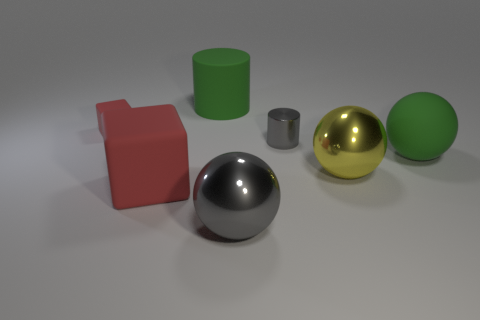There is a gray ball that is made of the same material as the small gray object; what size is it?
Your response must be concise. Large. The cylinder that is made of the same material as the tiny cube is what color?
Make the answer very short. Green. Is there a gray shiny object of the same size as the yellow metal sphere?
Keep it short and to the point. Yes. There is another green thing that is the same shape as the small metal object; what is it made of?
Keep it short and to the point. Rubber. There is a red rubber object that is the same size as the yellow shiny object; what is its shape?
Give a very brief answer. Cube. Is there a big object of the same shape as the small red rubber object?
Offer a very short reply. Yes. What is the shape of the metal thing that is in front of the red matte cube to the right of the small cube?
Make the answer very short. Sphere. What is the shape of the small red matte object?
Give a very brief answer. Cube. There is a tiny thing behind the cylinder in front of the red cube that is behind the yellow metallic sphere; what is it made of?
Your answer should be very brief. Rubber. What number of other objects are the same material as the small cylinder?
Your answer should be very brief. 2. 